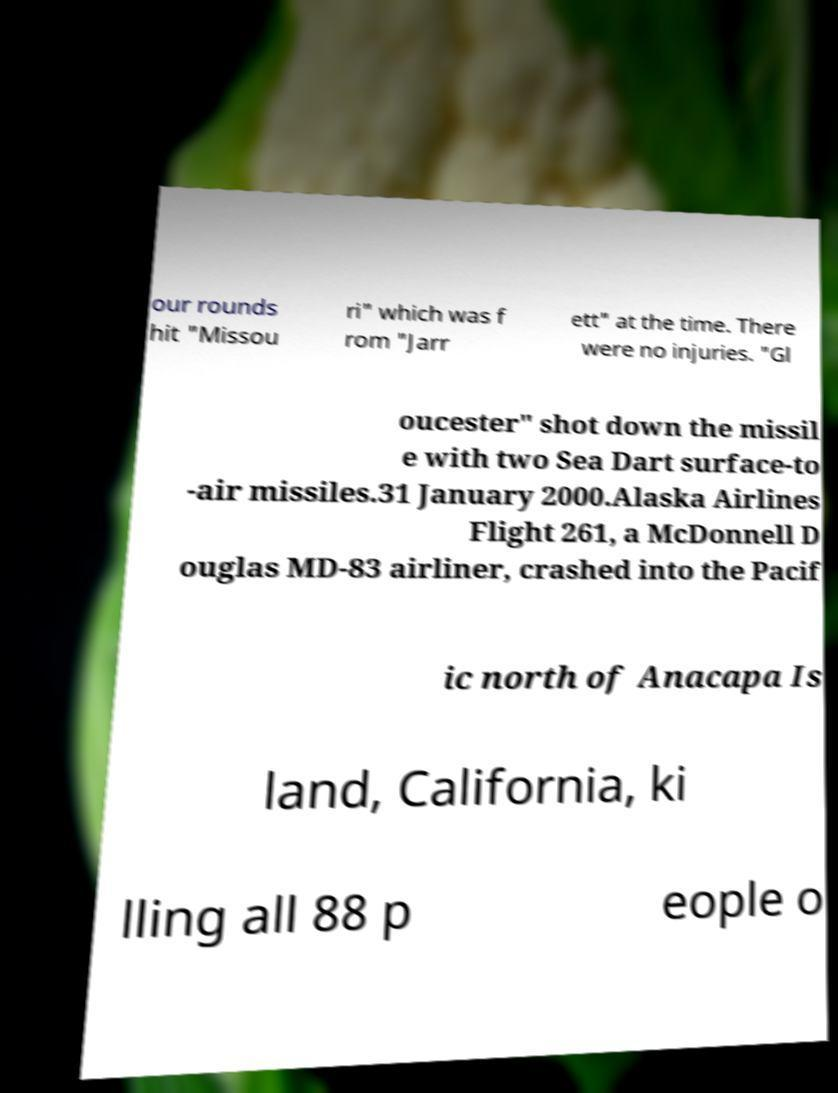Can you accurately transcribe the text from the provided image for me? our rounds hit "Missou ri" which was f rom "Jarr ett" at the time. There were no injuries. "Gl oucester" shot down the missil e with two Sea Dart surface-to -air missiles.31 January 2000.Alaska Airlines Flight 261, a McDonnell D ouglas MD-83 airliner, crashed into the Pacif ic north of Anacapa Is land, California, ki lling all 88 p eople o 